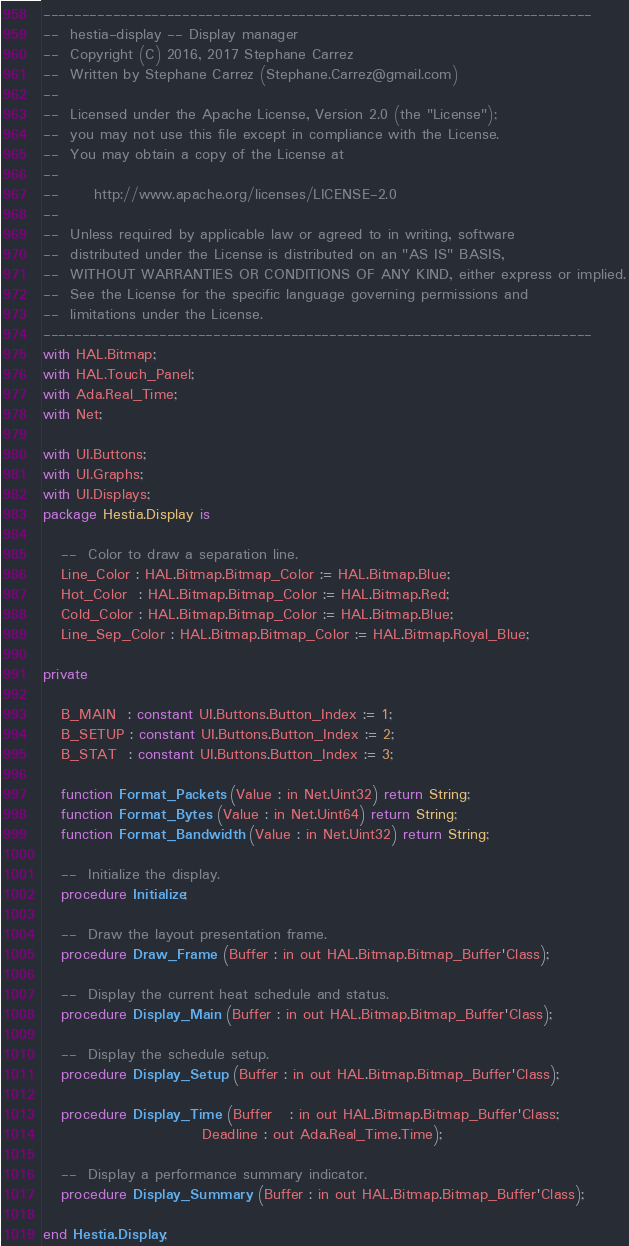<code> <loc_0><loc_0><loc_500><loc_500><_Ada_>-----------------------------------------------------------------------
--  hestia-display -- Display manager
--  Copyright (C) 2016, 2017 Stephane Carrez
--  Written by Stephane Carrez (Stephane.Carrez@gmail.com)
--
--  Licensed under the Apache License, Version 2.0 (the "License");
--  you may not use this file except in compliance with the License.
--  You may obtain a copy of the License at
--
--      http://www.apache.org/licenses/LICENSE-2.0
--
--  Unless required by applicable law or agreed to in writing, software
--  distributed under the License is distributed on an "AS IS" BASIS,
--  WITHOUT WARRANTIES OR CONDITIONS OF ANY KIND, either express or implied.
--  See the License for the specific language governing permissions and
--  limitations under the License.
-----------------------------------------------------------------------
with HAL.Bitmap;
with HAL.Touch_Panel;
with Ada.Real_Time;
with Net;

with UI.Buttons;
with UI.Graphs;
with UI.Displays;
package Hestia.Display is

   --  Color to draw a separation line.
   Line_Color : HAL.Bitmap.Bitmap_Color := HAL.Bitmap.Blue;
   Hot_Color  : HAL.Bitmap.Bitmap_Color := HAL.Bitmap.Red;
   Cold_Color : HAL.Bitmap.Bitmap_Color := HAL.Bitmap.Blue;
   Line_Sep_Color : HAL.Bitmap.Bitmap_Color := HAL.Bitmap.Royal_Blue;

private

   B_MAIN  : constant UI.Buttons.Button_Index := 1;
   B_SETUP : constant UI.Buttons.Button_Index := 2;
   B_STAT  : constant UI.Buttons.Button_Index := 3;

   function Format_Packets (Value : in Net.Uint32) return String;
   function Format_Bytes (Value : in Net.Uint64) return String;
   function Format_Bandwidth (Value : in Net.Uint32) return String;

   --  Initialize the display.
   procedure Initialize;

   --  Draw the layout presentation frame.
   procedure Draw_Frame (Buffer : in out HAL.Bitmap.Bitmap_Buffer'Class);

   --  Display the current heat schedule and status.
   procedure Display_Main (Buffer : in out HAL.Bitmap.Bitmap_Buffer'Class);

   --  Display the schedule setup.
   procedure Display_Setup (Buffer : in out HAL.Bitmap.Bitmap_Buffer'Class);

   procedure Display_Time (Buffer   : in out HAL.Bitmap.Bitmap_Buffer'Class;
                           Deadline : out Ada.Real_Time.Time);

   --  Display a performance summary indicator.
   procedure Display_Summary (Buffer : in out HAL.Bitmap.Bitmap_Buffer'Class);

end Hestia.Display;
</code> 